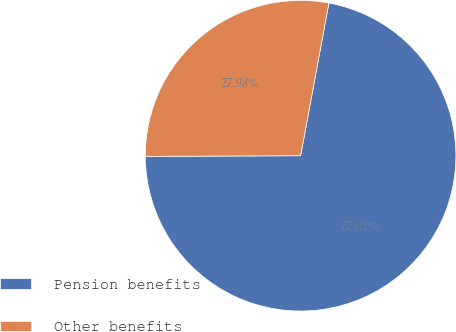Convert chart to OTSL. <chart><loc_0><loc_0><loc_500><loc_500><pie_chart><fcel>Pension benefits<fcel>Other benefits<nl><fcel>72.02%<fcel>27.98%<nl></chart> 